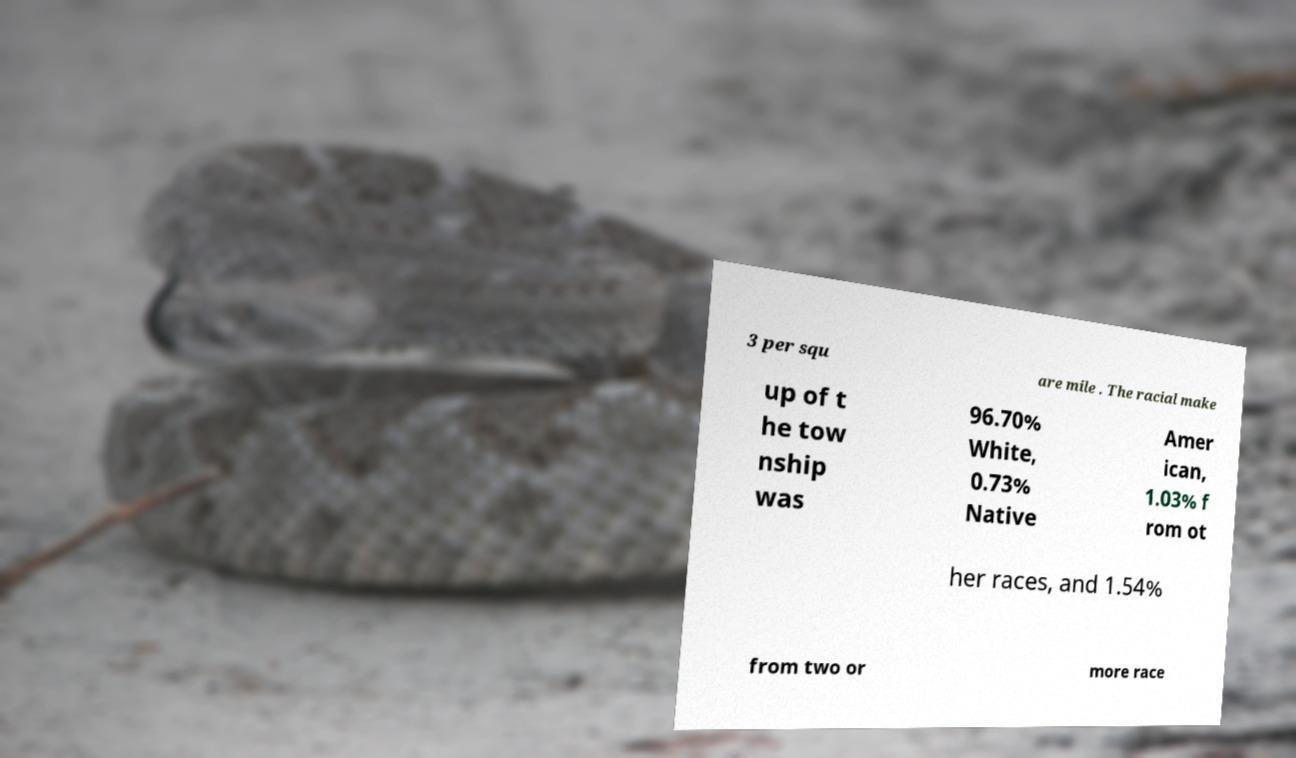I need the written content from this picture converted into text. Can you do that? 3 per squ are mile . The racial make up of t he tow nship was 96.70% White, 0.73% Native Amer ican, 1.03% f rom ot her races, and 1.54% from two or more race 